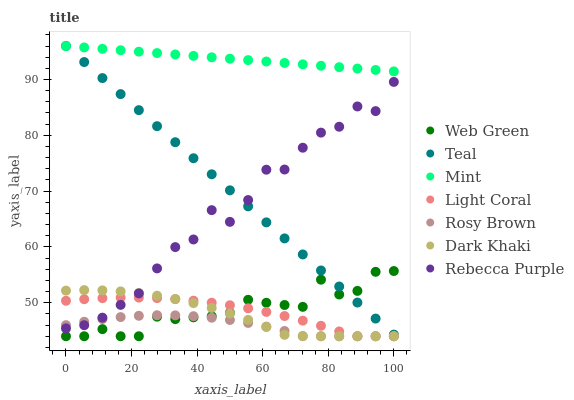Does Rosy Brown have the minimum area under the curve?
Answer yes or no. Yes. Does Mint have the maximum area under the curve?
Answer yes or no. Yes. Does Web Green have the minimum area under the curve?
Answer yes or no. No. Does Web Green have the maximum area under the curve?
Answer yes or no. No. Is Teal the smoothest?
Answer yes or no. Yes. Is Rebecca Purple the roughest?
Answer yes or no. Yes. Is Rosy Brown the smoothest?
Answer yes or no. No. Is Rosy Brown the roughest?
Answer yes or no. No. Does Dark Khaki have the lowest value?
Answer yes or no. Yes. Does Rebecca Purple have the lowest value?
Answer yes or no. No. Does Mint have the highest value?
Answer yes or no. Yes. Does Web Green have the highest value?
Answer yes or no. No. Is Rebecca Purple less than Mint?
Answer yes or no. Yes. Is Mint greater than Light Coral?
Answer yes or no. Yes. Does Rebecca Purple intersect Teal?
Answer yes or no. Yes. Is Rebecca Purple less than Teal?
Answer yes or no. No. Is Rebecca Purple greater than Teal?
Answer yes or no. No. Does Rebecca Purple intersect Mint?
Answer yes or no. No. 